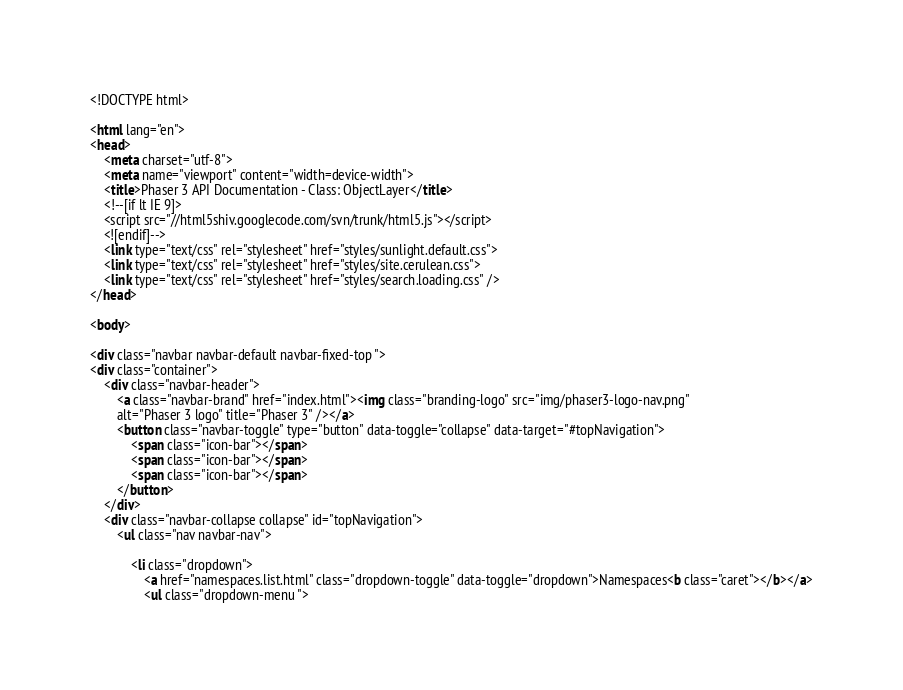<code> <loc_0><loc_0><loc_500><loc_500><_HTML_><!DOCTYPE html>

<html lang="en">
<head>
	<meta charset="utf-8">
	<meta name="viewport" content="width=device-width">
	<title>Phaser 3 API Documentation - Class: ObjectLayer</title>
	<!--[if lt IE 9]>
	<script src="//html5shiv.googlecode.com/svn/trunk/html5.js"></script>
	<![endif]-->
	<link type="text/css" rel="stylesheet" href="styles/sunlight.default.css">
	<link type="text/css" rel="stylesheet" href="styles/site.cerulean.css">
	<link type="text/css" rel="stylesheet" href="styles/search.loading.css" />
</head>

<body>

<div class="navbar navbar-default navbar-fixed-top ">
<div class="container">
	<div class="navbar-header">
		<a class="navbar-brand" href="index.html"><img class="branding-logo" src="img/phaser3-logo-nav.png"
		alt="Phaser 3 logo" title="Phaser 3" /></a>
		<button class="navbar-toggle" type="button" data-toggle="collapse" data-target="#topNavigation">
			<span class="icon-bar"></span>
			<span class="icon-bar"></span>
			<span class="icon-bar"></span>
        </button>
	</div>
	<div class="navbar-collapse collapse" id="topNavigation">
		<ul class="nav navbar-nav">
			
			<li class="dropdown">
				<a href="namespaces.list.html" class="dropdown-toggle" data-toggle="dropdown">Namespaces<b class="caret"></b></a>
				<ul class="dropdown-menu "></code> 